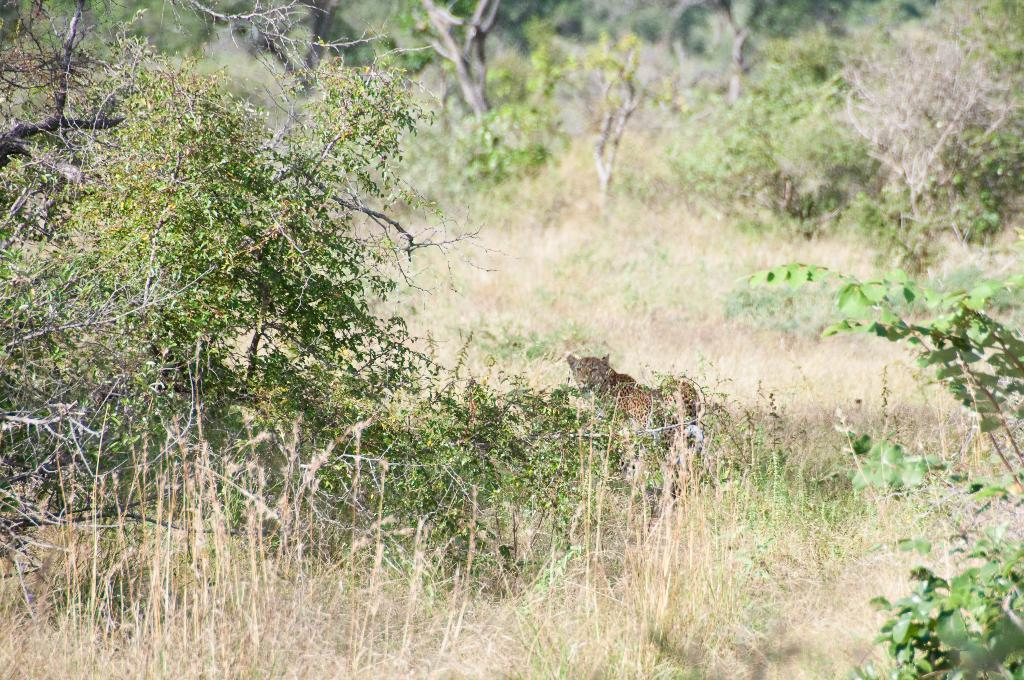What animal is in the center of the image? There is a cheetah in the center of the image. What can be seen in the background of the image? There are trees and grass in the background of the image. What type of prose is being recited by the cheetah in the image? There is no indication in the image that the cheetah is reciting any prose, as cheetahs are animals and do not have the ability to speak or recite literature. 